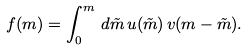<formula> <loc_0><loc_0><loc_500><loc_500>f ( m ) = \int _ { 0 } ^ { m } \, d { \tilde { m } } \, u ( \tilde { m } ) \, v ( m - \tilde { m } ) .</formula> 